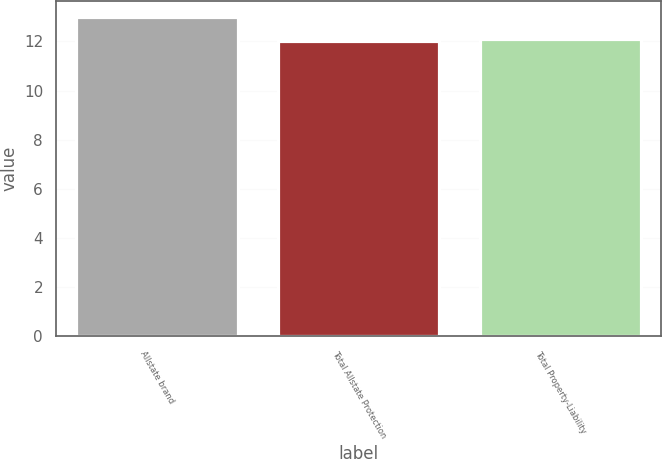Convert chart to OTSL. <chart><loc_0><loc_0><loc_500><loc_500><bar_chart><fcel>Allstate brand<fcel>Total Allstate Protection<fcel>Total Property-Liability<nl><fcel>13<fcel>12<fcel>12.1<nl></chart> 